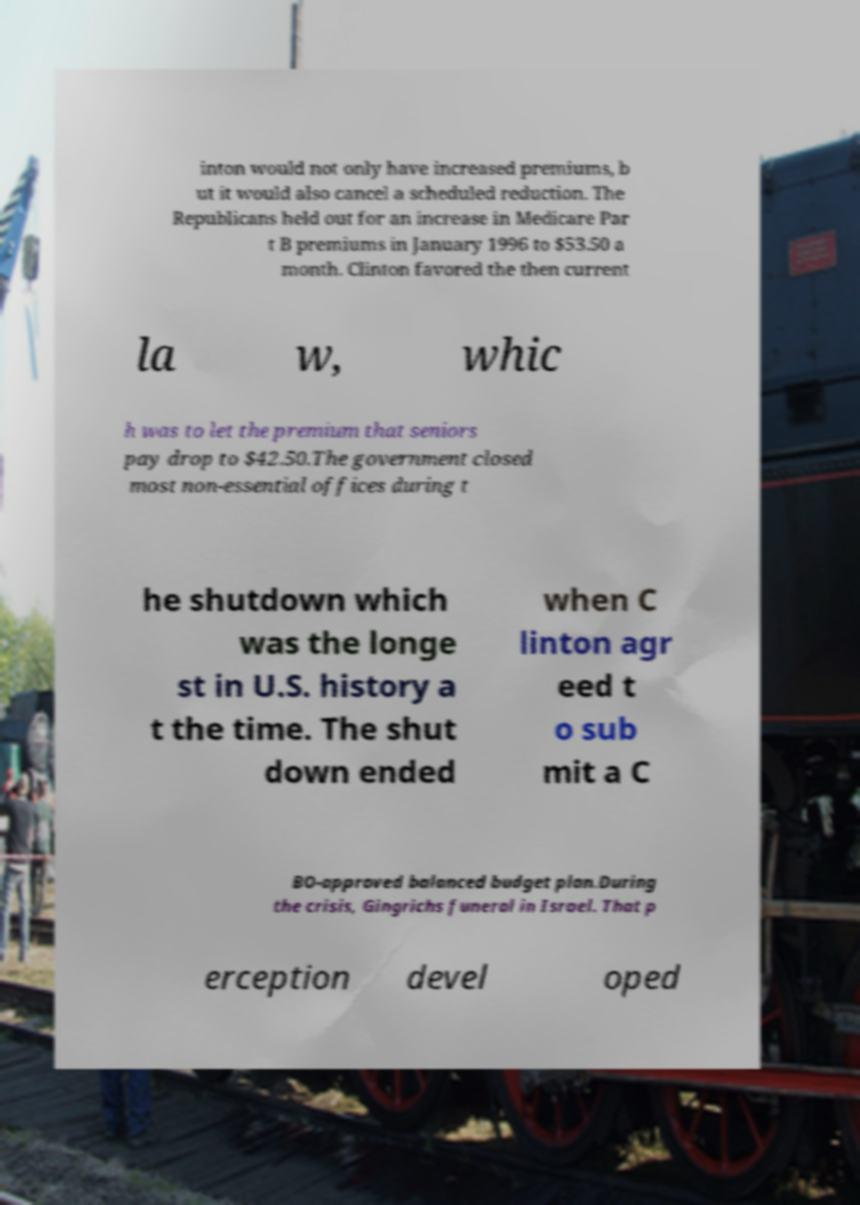Can you read and provide the text displayed in the image?This photo seems to have some interesting text. Can you extract and type it out for me? inton would not only have increased premiums, b ut it would also cancel a scheduled reduction. The Republicans held out for an increase in Medicare Par t B premiums in January 1996 to $53.50 a month. Clinton favored the then current la w, whic h was to let the premium that seniors pay drop to $42.50.The government closed most non-essential offices during t he shutdown which was the longe st in U.S. history a t the time. The shut down ended when C linton agr eed t o sub mit a C BO-approved balanced budget plan.During the crisis, Gingrichs funeral in Israel. That p erception devel oped 